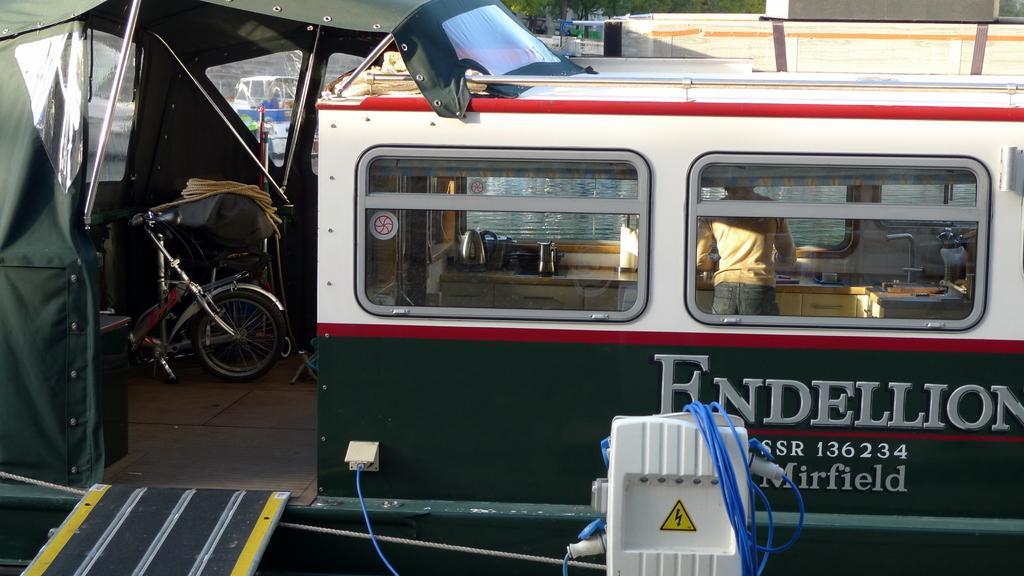Please provide a concise description of this image. There is a ship in the center of the image, there is a person, bicycle and kitchenware inside it, there is an electric box and wires at the bottom side and there is greenery and other ships on the water in the background area. 